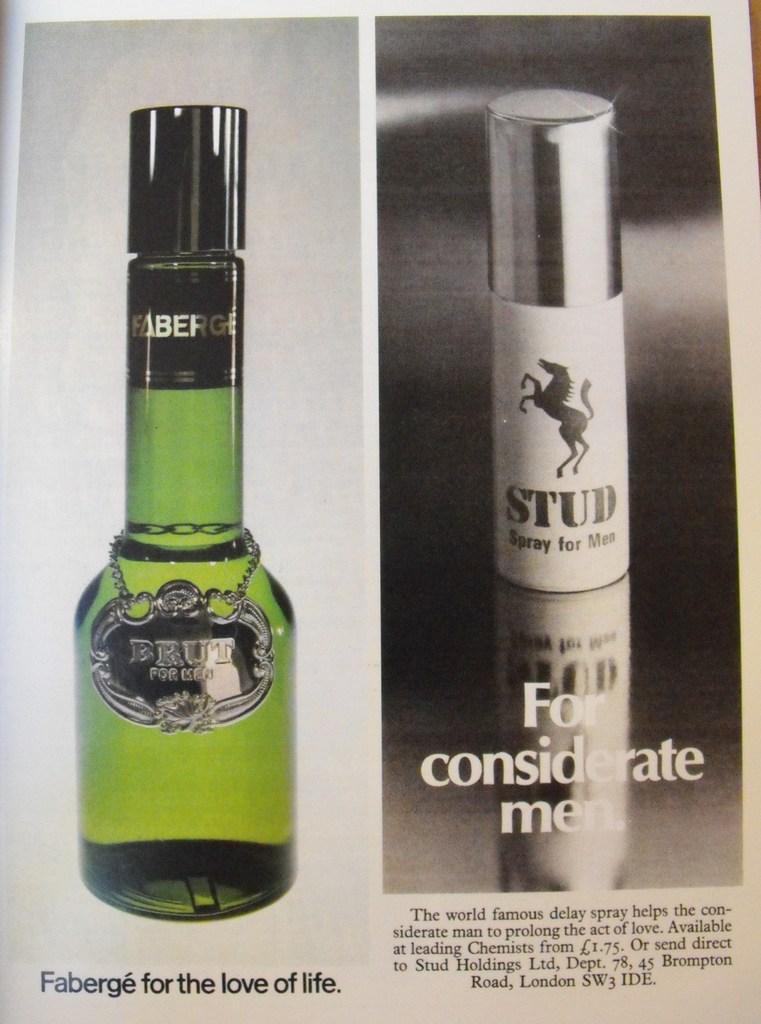Provide a one-sentence caption for the provided image. Stud spray for men and Faberge for the love of life in a magazine. 